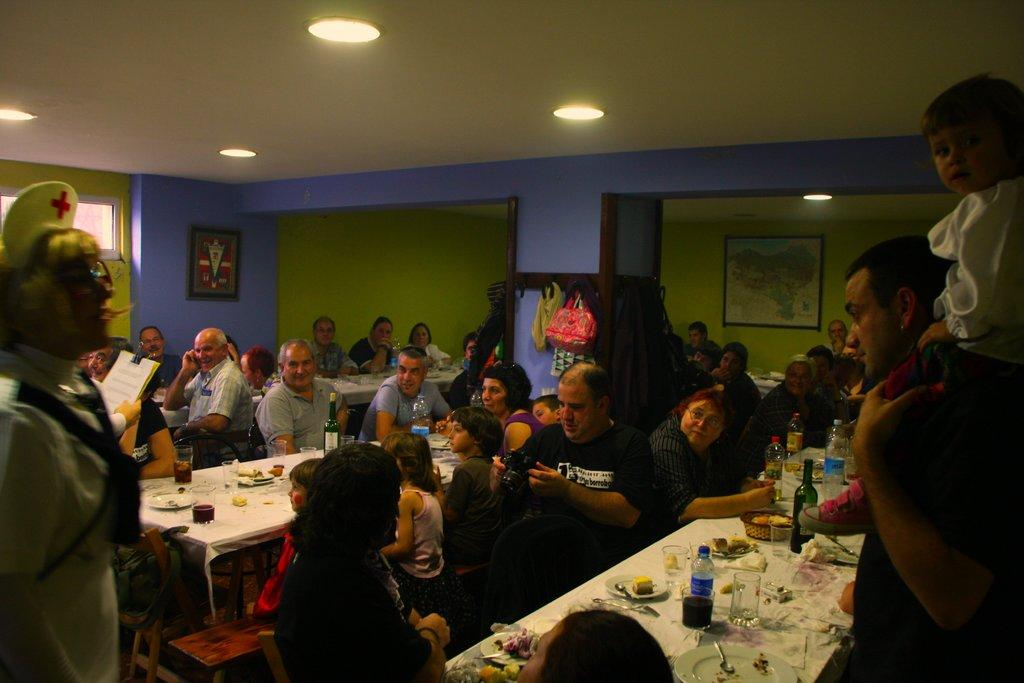What are the people in the image doing? Some people are standing, and some are sitting in the image. What is in front of the people? There is a table in front of the people. What can be found on the table? There are water bottles and food stuff on the table. What type of carriage is being used to transport the food in the image? There is no carriage present in the image; the food is on a table. What kind of amusement can be seen in the image? There is no amusement depicted in the image; it shows people standing and sitting around a table with food and water bottles. 